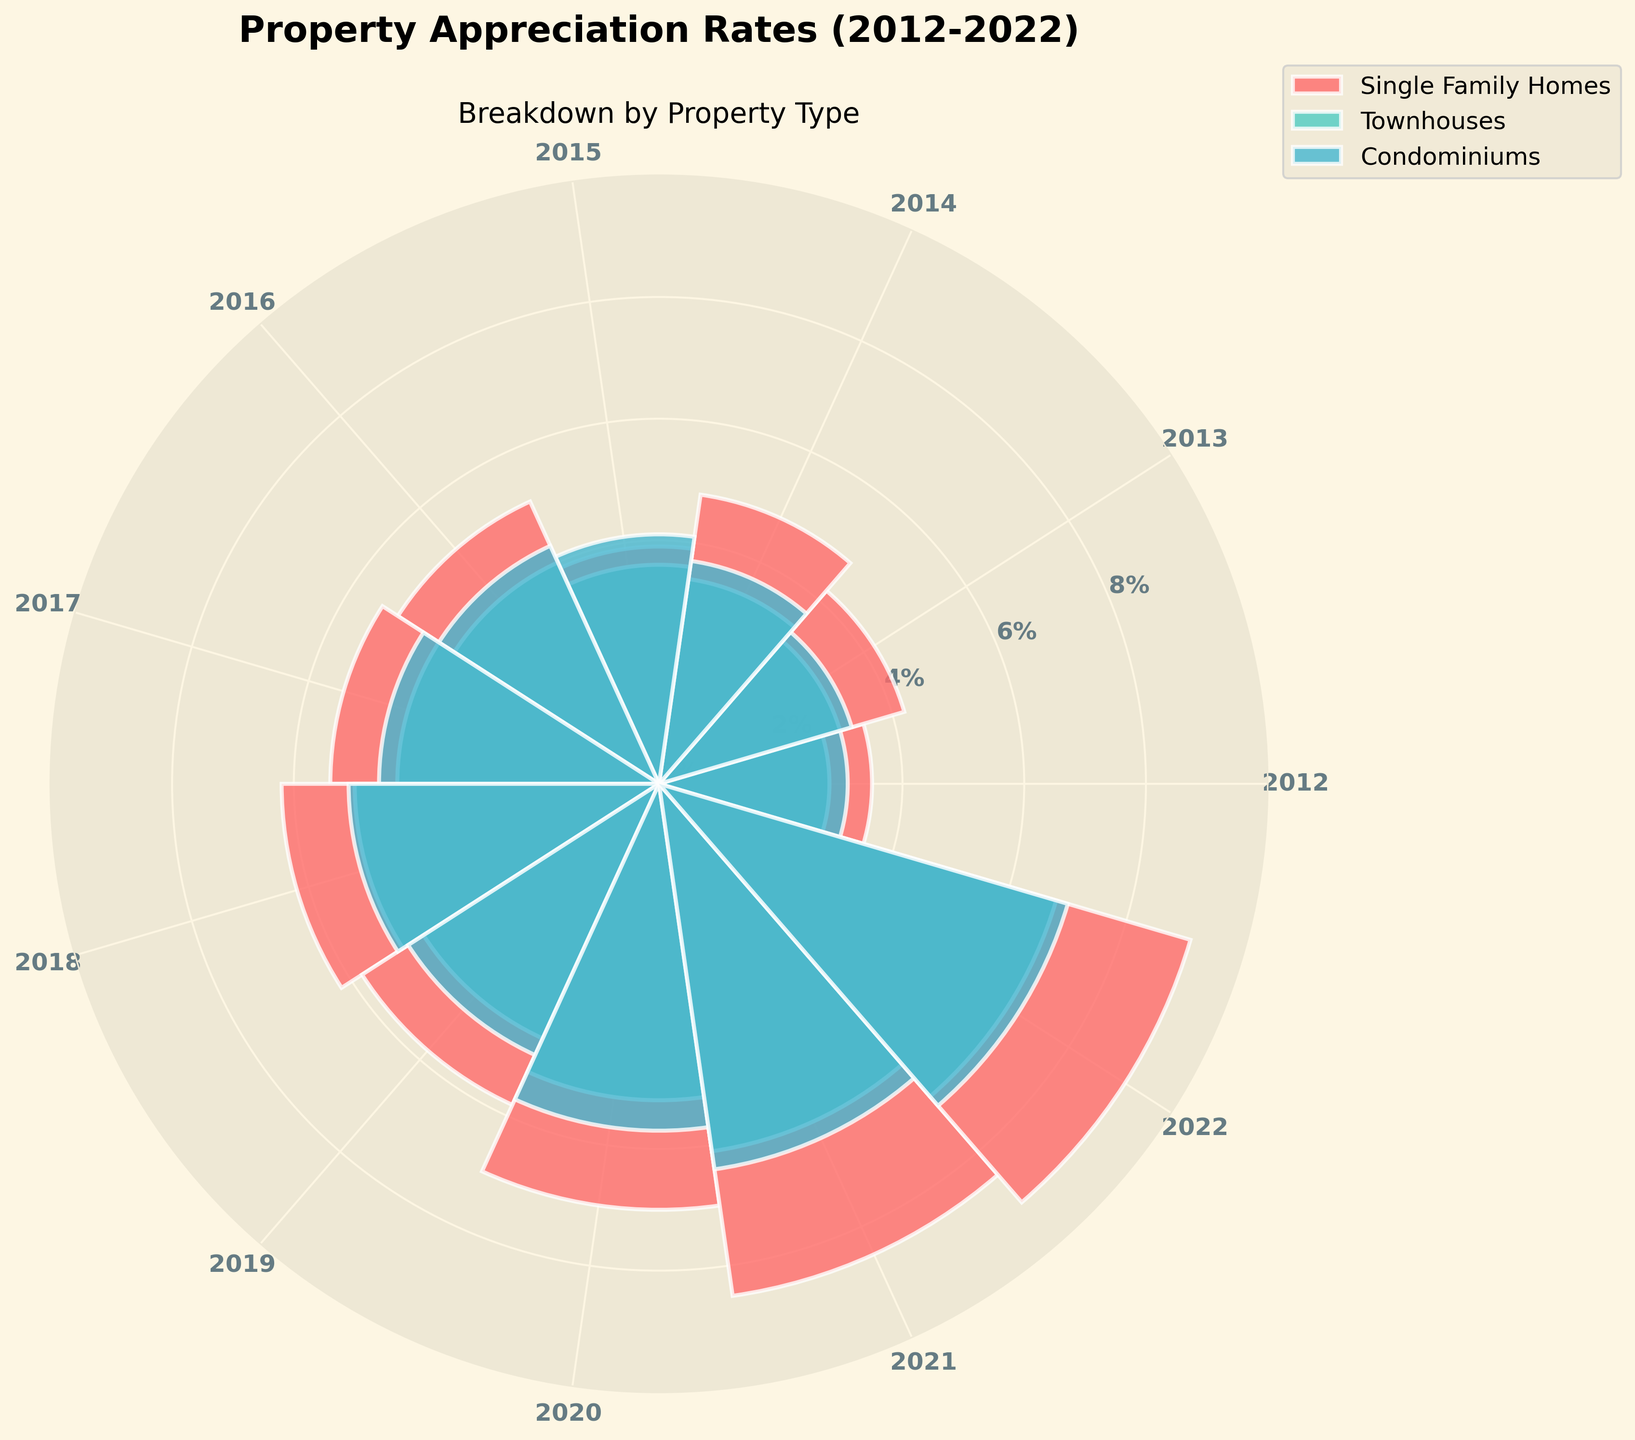What is the title of the figure? The title is displayed at the top of the figure in large bold font.
Answer: Property Appreciation Rates (2012-2022) How many property types are represented in the figure? The legend shows the number of categories and there are three different colors representing three groups.
Answer: Three Which property type had the highest appreciation rate in 2022? By looking at the data points for 2022 at the edge of the chart and comparing their heights, the color corresponding to Single Family Homes reaches the farthest.
Answer: Single Family Homes What are the average appreciation rates of Condominiums between 2015 and 2018? The average is calculated by summing the values for Condominiums from 2015 to 2018 and dividing by the number of years, so (4.1 + 4.3 + 4.6 + 5.1) / 4.
Answer: 4.53% Which property type saw a greater increase in appreciation rate from 2017 to 2018, Single Family Homes or Townhouses? Subtract the 2017 values from the 2018 values for each property type, then compare the differences: Single Family Homes (6.2 - 5.4) and Townhouses (5.0 - 4.3).
Answer: Single Family Homes In which year did Townhouses have the smallest appreciation rate? Examine the shortest bar segment for Townhouses across all the years; the smallest value is in 2012.
Answer: 2012 Compare the appreciation rate of Single Family Homes and Condominiums in 2020. Which one is higher? By looking at the respective bars for 2020, the length of the bar for Single Family Homes is greater than that for Condominiums.
Answer: Single Family Homes Is there any year where the appreciation rate of Condominiums is equal to Townhouses? Compare the values of Condominiums and Townhouses for each year; there is no year where they are the same value.
Answer: No Which property type consistently showed an increase in appreciation rate every year from 2012 to 2022? Check the trend for each property type across all years to see which one does not decrease in any year; Single Family Homes have a consistent increase.
Answer: Single Family Homes What is the average appreciation rate for all property types in 2015? For each property type in 2015, sum the rates and divide by the number of property types: (3.9 + 3.6 + 4.1) / 3.
Answer: 3.87% 